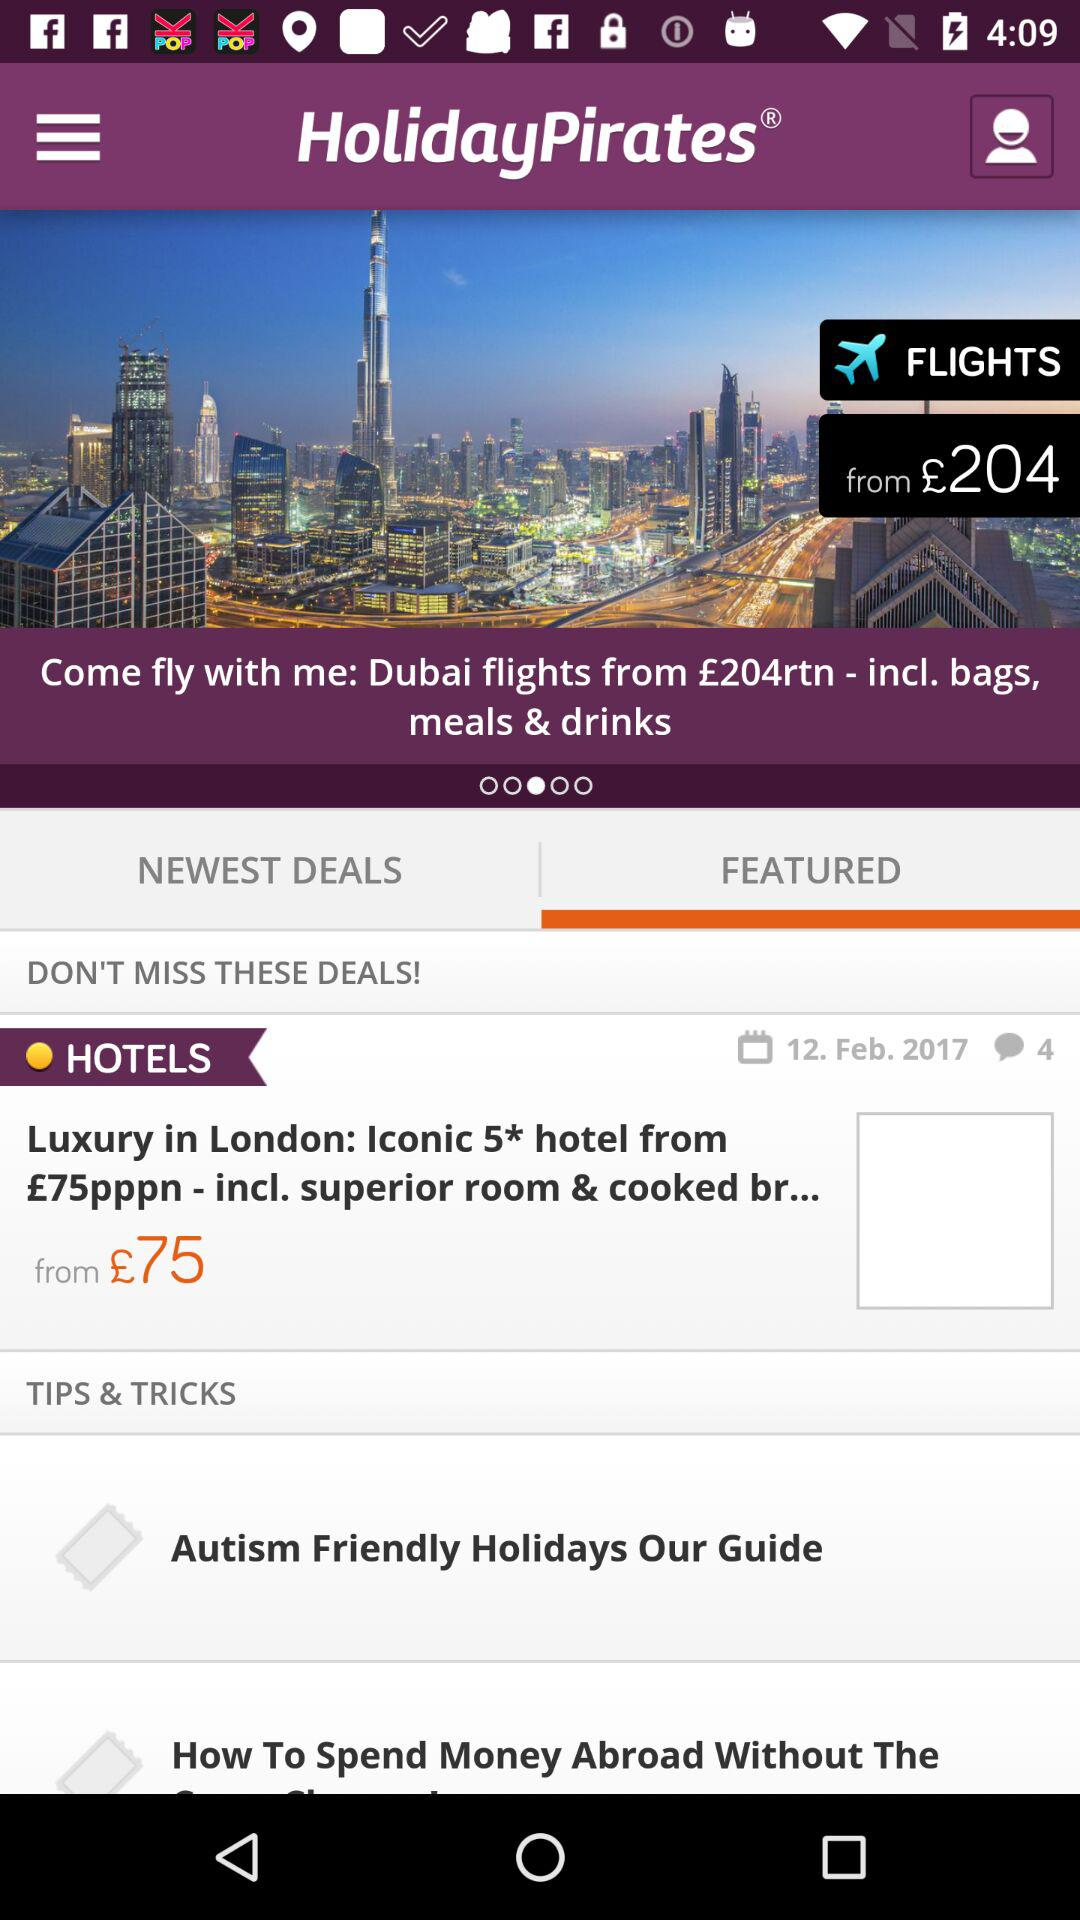What is the starting price for Dubai flights? The starting price is £204. 